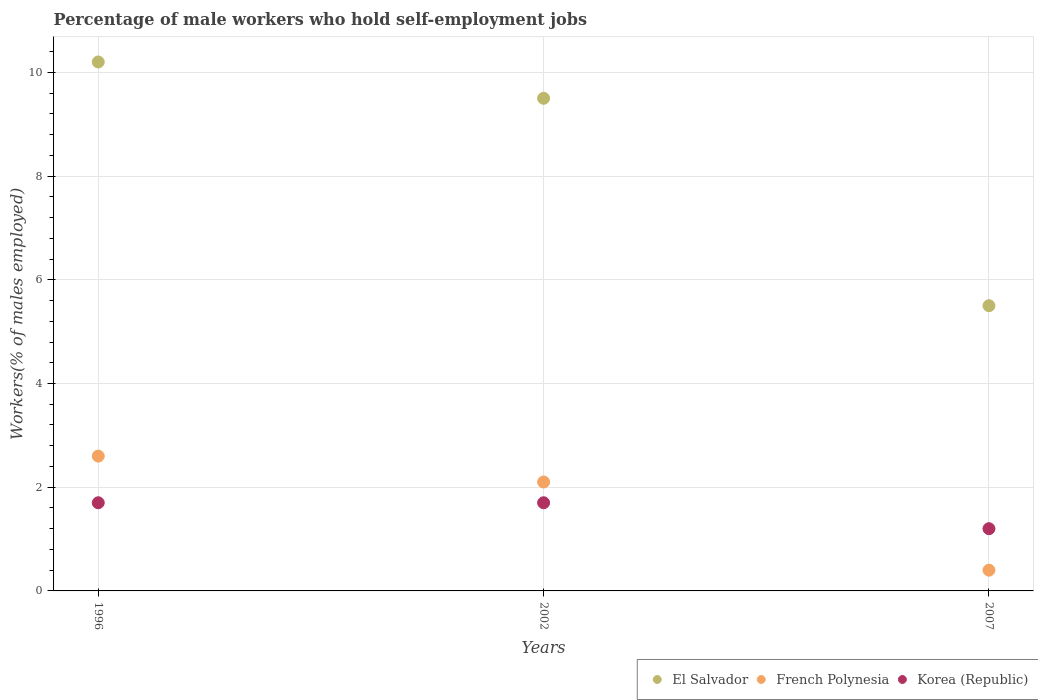How many different coloured dotlines are there?
Your response must be concise. 3. Is the number of dotlines equal to the number of legend labels?
Offer a terse response. Yes. What is the percentage of self-employed male workers in Korea (Republic) in 2002?
Your response must be concise. 1.7. Across all years, what is the maximum percentage of self-employed male workers in French Polynesia?
Give a very brief answer. 2.6. Across all years, what is the minimum percentage of self-employed male workers in French Polynesia?
Provide a short and direct response. 0.4. What is the total percentage of self-employed male workers in El Salvador in the graph?
Your answer should be very brief. 25.2. What is the difference between the percentage of self-employed male workers in French Polynesia in 2002 and the percentage of self-employed male workers in Korea (Republic) in 2007?
Your answer should be very brief. 0.9. What is the average percentage of self-employed male workers in French Polynesia per year?
Give a very brief answer. 1.7. In the year 1996, what is the difference between the percentage of self-employed male workers in Korea (Republic) and percentage of self-employed male workers in French Polynesia?
Make the answer very short. -0.9. What is the ratio of the percentage of self-employed male workers in Korea (Republic) in 2002 to that in 2007?
Offer a terse response. 1.42. Is the percentage of self-employed male workers in French Polynesia in 2002 less than that in 2007?
Your answer should be compact. No. Is the difference between the percentage of self-employed male workers in Korea (Republic) in 1996 and 2007 greater than the difference between the percentage of self-employed male workers in French Polynesia in 1996 and 2007?
Ensure brevity in your answer.  No. What is the difference between the highest and the lowest percentage of self-employed male workers in El Salvador?
Give a very brief answer. 4.7. Is it the case that in every year, the sum of the percentage of self-employed male workers in French Polynesia and percentage of self-employed male workers in El Salvador  is greater than the percentage of self-employed male workers in Korea (Republic)?
Provide a short and direct response. Yes. Does the percentage of self-employed male workers in Korea (Republic) monotonically increase over the years?
Offer a very short reply. No. Is the percentage of self-employed male workers in El Salvador strictly greater than the percentage of self-employed male workers in French Polynesia over the years?
Keep it short and to the point. Yes. How many years are there in the graph?
Give a very brief answer. 3. Are the values on the major ticks of Y-axis written in scientific E-notation?
Ensure brevity in your answer.  No. Does the graph contain any zero values?
Provide a succinct answer. No. Does the graph contain grids?
Make the answer very short. Yes. How many legend labels are there?
Offer a terse response. 3. What is the title of the graph?
Keep it short and to the point. Percentage of male workers who hold self-employment jobs. What is the label or title of the X-axis?
Your response must be concise. Years. What is the label or title of the Y-axis?
Keep it short and to the point. Workers(% of males employed). What is the Workers(% of males employed) of El Salvador in 1996?
Offer a very short reply. 10.2. What is the Workers(% of males employed) of French Polynesia in 1996?
Offer a very short reply. 2.6. What is the Workers(% of males employed) of Korea (Republic) in 1996?
Your response must be concise. 1.7. What is the Workers(% of males employed) of El Salvador in 2002?
Make the answer very short. 9.5. What is the Workers(% of males employed) in French Polynesia in 2002?
Ensure brevity in your answer.  2.1. What is the Workers(% of males employed) of Korea (Republic) in 2002?
Keep it short and to the point. 1.7. What is the Workers(% of males employed) in El Salvador in 2007?
Ensure brevity in your answer.  5.5. What is the Workers(% of males employed) of French Polynesia in 2007?
Keep it short and to the point. 0.4. What is the Workers(% of males employed) in Korea (Republic) in 2007?
Ensure brevity in your answer.  1.2. Across all years, what is the maximum Workers(% of males employed) of El Salvador?
Ensure brevity in your answer.  10.2. Across all years, what is the maximum Workers(% of males employed) of French Polynesia?
Offer a very short reply. 2.6. Across all years, what is the maximum Workers(% of males employed) of Korea (Republic)?
Offer a terse response. 1.7. Across all years, what is the minimum Workers(% of males employed) in French Polynesia?
Keep it short and to the point. 0.4. Across all years, what is the minimum Workers(% of males employed) in Korea (Republic)?
Provide a short and direct response. 1.2. What is the total Workers(% of males employed) in El Salvador in the graph?
Your answer should be compact. 25.2. What is the total Workers(% of males employed) in French Polynesia in the graph?
Your response must be concise. 5.1. What is the total Workers(% of males employed) of Korea (Republic) in the graph?
Make the answer very short. 4.6. What is the difference between the Workers(% of males employed) in Korea (Republic) in 1996 and that in 2002?
Give a very brief answer. 0. What is the difference between the Workers(% of males employed) of El Salvador in 1996 and that in 2007?
Your answer should be compact. 4.7. What is the difference between the Workers(% of males employed) of French Polynesia in 1996 and that in 2007?
Offer a terse response. 2.2. What is the difference between the Workers(% of males employed) in Korea (Republic) in 2002 and that in 2007?
Your answer should be very brief. 0.5. What is the difference between the Workers(% of males employed) in El Salvador in 1996 and the Workers(% of males employed) in French Polynesia in 2002?
Ensure brevity in your answer.  8.1. What is the difference between the Workers(% of males employed) of French Polynesia in 1996 and the Workers(% of males employed) of Korea (Republic) in 2002?
Offer a terse response. 0.9. What is the average Workers(% of males employed) of El Salvador per year?
Make the answer very short. 8.4. What is the average Workers(% of males employed) in French Polynesia per year?
Provide a short and direct response. 1.7. What is the average Workers(% of males employed) in Korea (Republic) per year?
Your answer should be compact. 1.53. In the year 1996, what is the difference between the Workers(% of males employed) in El Salvador and Workers(% of males employed) in Korea (Republic)?
Offer a very short reply. 8.5. In the year 1996, what is the difference between the Workers(% of males employed) of French Polynesia and Workers(% of males employed) of Korea (Republic)?
Your answer should be compact. 0.9. In the year 2002, what is the difference between the Workers(% of males employed) of El Salvador and Workers(% of males employed) of French Polynesia?
Your answer should be very brief. 7.4. In the year 2002, what is the difference between the Workers(% of males employed) in French Polynesia and Workers(% of males employed) in Korea (Republic)?
Give a very brief answer. 0.4. In the year 2007, what is the difference between the Workers(% of males employed) of El Salvador and Workers(% of males employed) of Korea (Republic)?
Give a very brief answer. 4.3. In the year 2007, what is the difference between the Workers(% of males employed) of French Polynesia and Workers(% of males employed) of Korea (Republic)?
Offer a very short reply. -0.8. What is the ratio of the Workers(% of males employed) in El Salvador in 1996 to that in 2002?
Keep it short and to the point. 1.07. What is the ratio of the Workers(% of males employed) in French Polynesia in 1996 to that in 2002?
Your answer should be very brief. 1.24. What is the ratio of the Workers(% of males employed) of Korea (Republic) in 1996 to that in 2002?
Offer a terse response. 1. What is the ratio of the Workers(% of males employed) in El Salvador in 1996 to that in 2007?
Provide a short and direct response. 1.85. What is the ratio of the Workers(% of males employed) in Korea (Republic) in 1996 to that in 2007?
Your answer should be compact. 1.42. What is the ratio of the Workers(% of males employed) in El Salvador in 2002 to that in 2007?
Make the answer very short. 1.73. What is the ratio of the Workers(% of males employed) in French Polynesia in 2002 to that in 2007?
Offer a terse response. 5.25. What is the ratio of the Workers(% of males employed) of Korea (Republic) in 2002 to that in 2007?
Keep it short and to the point. 1.42. What is the difference between the highest and the second highest Workers(% of males employed) of El Salvador?
Ensure brevity in your answer.  0.7. What is the difference between the highest and the second highest Workers(% of males employed) in French Polynesia?
Provide a succinct answer. 0.5. What is the difference between the highest and the lowest Workers(% of males employed) in El Salvador?
Give a very brief answer. 4.7. What is the difference between the highest and the lowest Workers(% of males employed) in French Polynesia?
Your answer should be very brief. 2.2. 